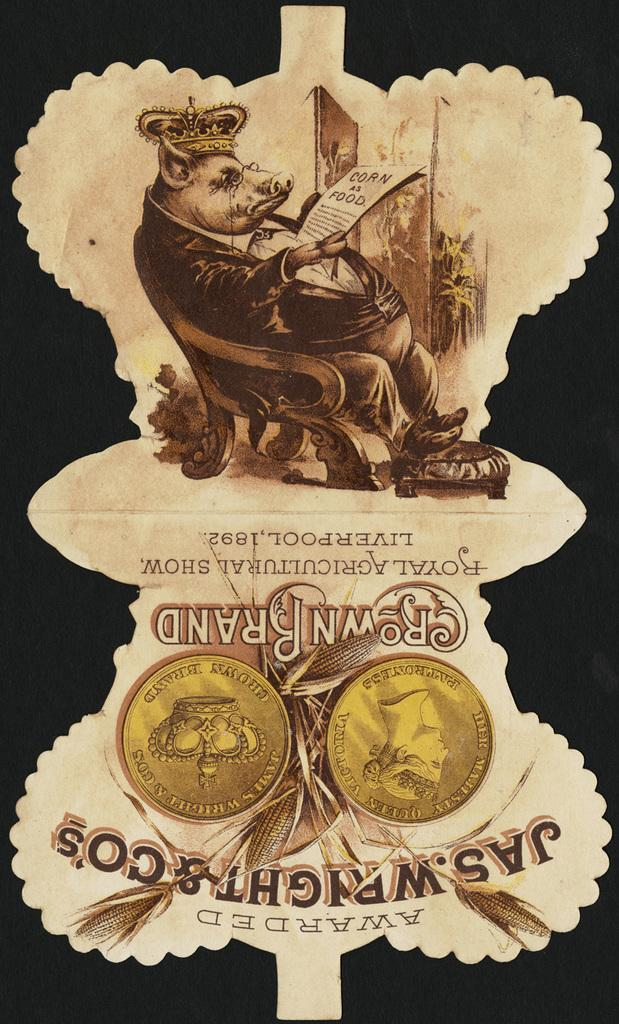Provide a one-sentence caption for the provided image. Label saying Crown Brand and a picture of a pig reading. 